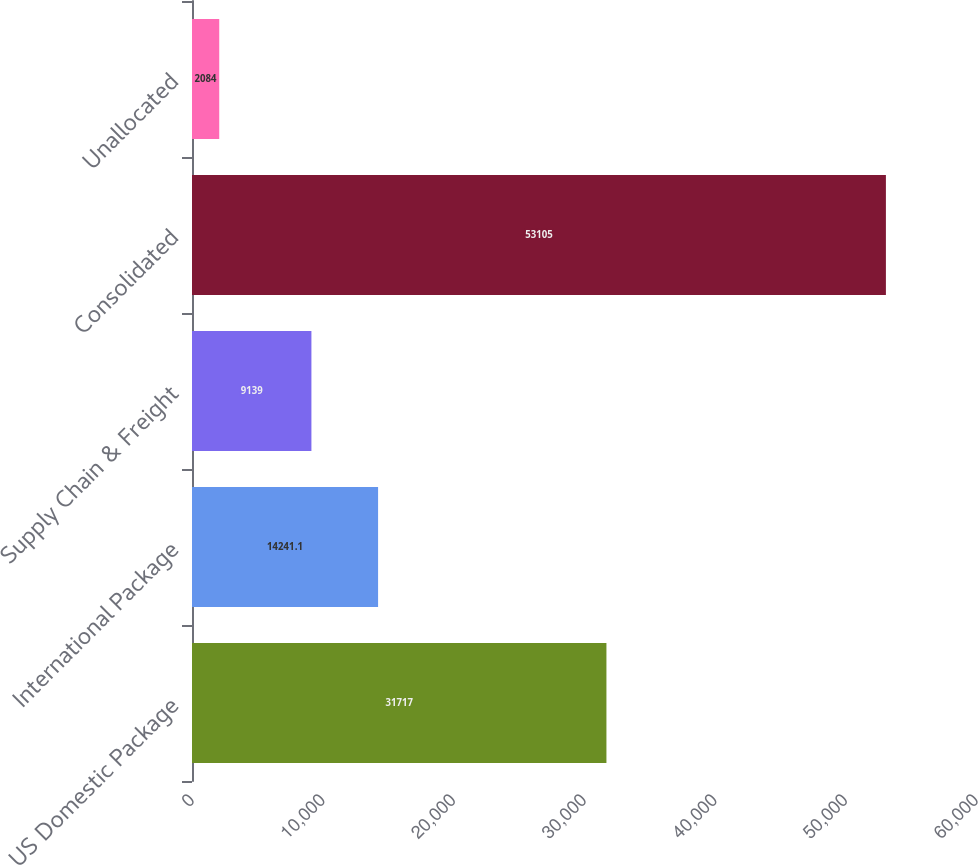Convert chart. <chart><loc_0><loc_0><loc_500><loc_500><bar_chart><fcel>US Domestic Package<fcel>International Package<fcel>Supply Chain & Freight<fcel>Consolidated<fcel>Unallocated<nl><fcel>31717<fcel>14241.1<fcel>9139<fcel>53105<fcel>2084<nl></chart> 